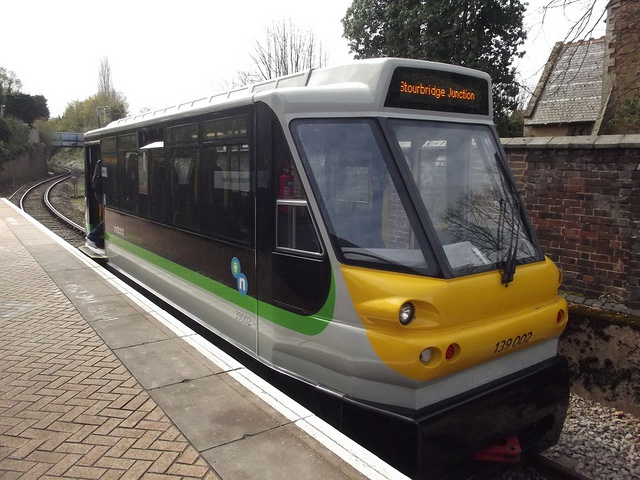Describe the objects in this image and their specific colors. I can see a train in white, black, gray, olive, and darkgray tones in this image. 